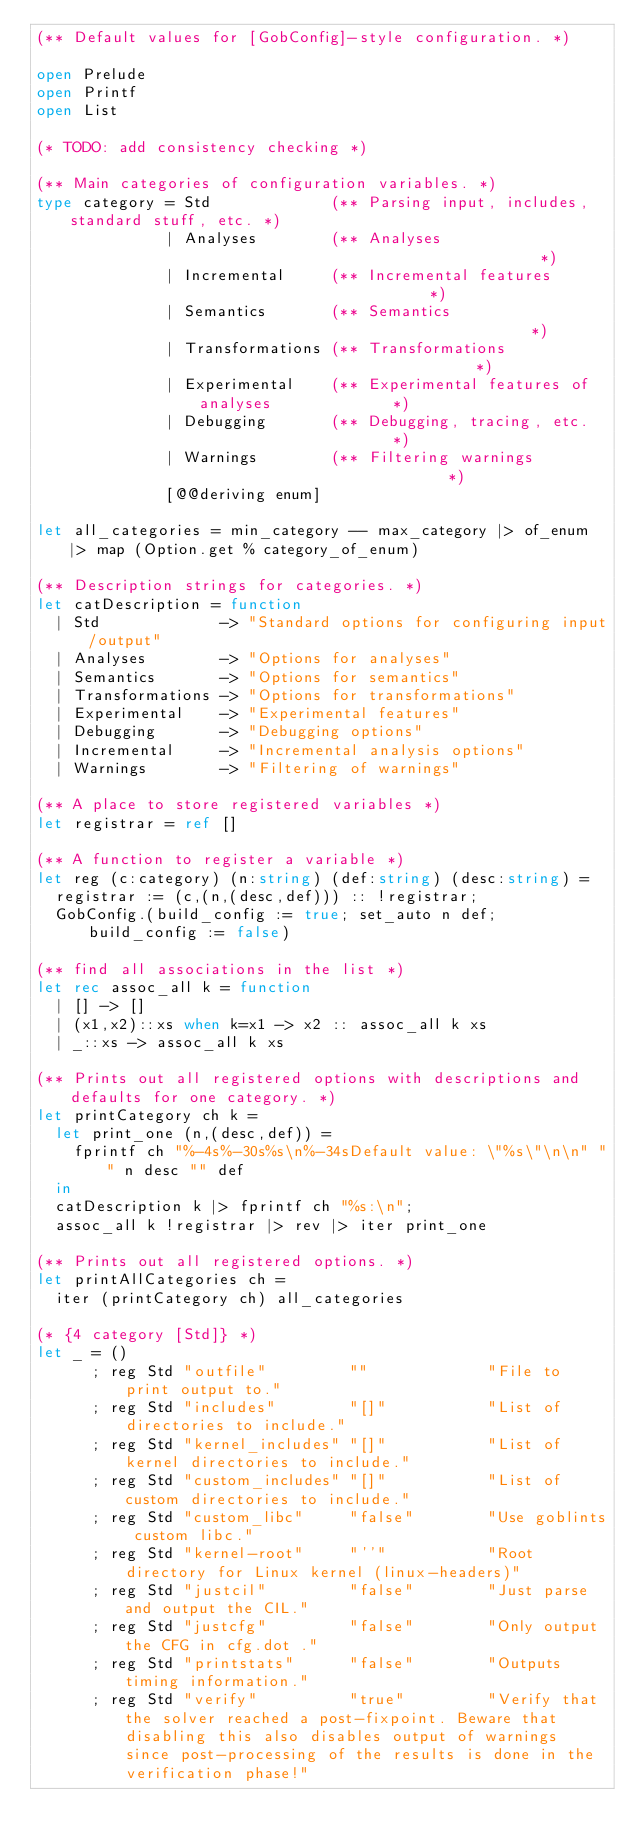<code> <loc_0><loc_0><loc_500><loc_500><_OCaml_>(** Default values for [GobConfig]-style configuration. *)

open Prelude
open Printf
open List

(* TODO: add consistency checking *)

(** Main categories of configuration variables. *)
type category = Std             (** Parsing input, includes, standard stuff, etc. *)
              | Analyses        (** Analyses                                      *)
              | Incremental     (** Incremental features                          *)
              | Semantics       (** Semantics                                     *)
              | Transformations (** Transformations                               *)
              | Experimental    (** Experimental features of analyses             *)
              | Debugging       (** Debugging, tracing, etc.                      *)
              | Warnings        (** Filtering warnings                            *)
              [@@deriving enum]

let all_categories = min_category -- max_category |> of_enum |> map (Option.get % category_of_enum)

(** Description strings for categories. *)
let catDescription = function
  | Std             -> "Standard options for configuring input/output"
  | Analyses        -> "Options for analyses"
  | Semantics       -> "Options for semantics"
  | Transformations -> "Options for transformations"
  | Experimental    -> "Experimental features"
  | Debugging       -> "Debugging options"
  | Incremental     -> "Incremental analysis options"
  | Warnings        -> "Filtering of warnings"

(** A place to store registered variables *)
let registrar = ref []

(** A function to register a variable *)
let reg (c:category) (n:string) (def:string) (desc:string) =
  registrar := (c,(n,(desc,def))) :: !registrar;
  GobConfig.(build_config := true; set_auto n def; build_config := false)

(** find all associations in the list *)
let rec assoc_all k = function
  | [] -> []
  | (x1,x2)::xs when k=x1 -> x2 :: assoc_all k xs
  | _::xs -> assoc_all k xs

(** Prints out all registered options with descriptions and defaults for one category. *)
let printCategory ch k =
  let print_one (n,(desc,def)) =
    fprintf ch "%-4s%-30s%s\n%-34sDefault value: \"%s\"\n\n" "" n desc "" def
  in
  catDescription k |> fprintf ch "%s:\n";
  assoc_all k !registrar |> rev |> iter print_one

(** Prints out all registered options. *)
let printAllCategories ch =
  iter (printCategory ch) all_categories

(* {4 category [Std]} *)
let _ = ()
      ; reg Std "outfile"         ""             "File to print output to."
      ; reg Std "includes"        "[]"           "List of directories to include."
      ; reg Std "kernel_includes" "[]"           "List of kernel directories to include."
      ; reg Std "custom_includes" "[]"           "List of custom directories to include."
      ; reg Std "custom_libc"     "false"        "Use goblints custom libc."
      ; reg Std "kernel-root"     "''"           "Root directory for Linux kernel (linux-headers)"
      ; reg Std "justcil"         "false"        "Just parse and output the CIL."
      ; reg Std "justcfg"         "false"        "Only output the CFG in cfg.dot ."
      ; reg Std "printstats"      "false"        "Outputs timing information."
      ; reg Std "verify"          "true"         "Verify that the solver reached a post-fixpoint. Beware that disabling this also disables output of warnings since post-processing of the results is done in the verification phase!"</code> 